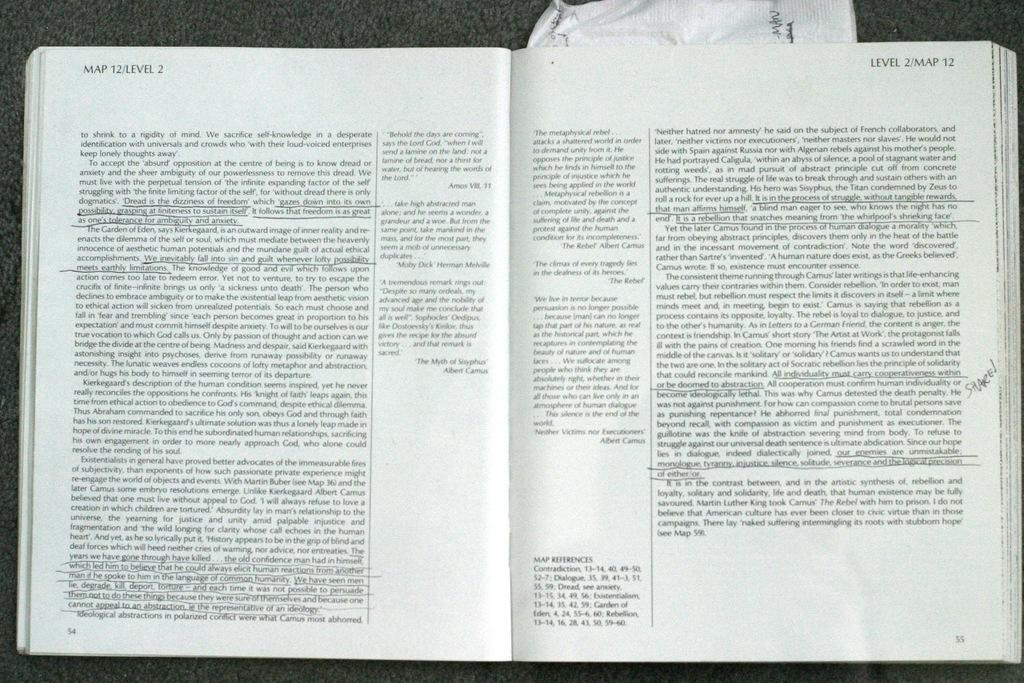Provide a one-sentence caption for the provided image. A book with underlined text is opened to Map 12 Level 2. 